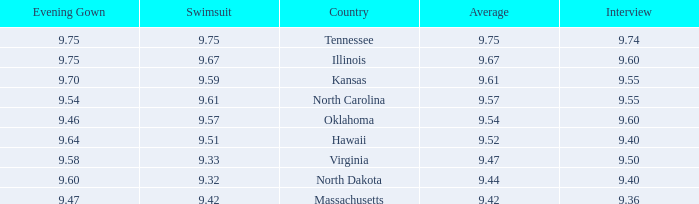67? Illinois. 